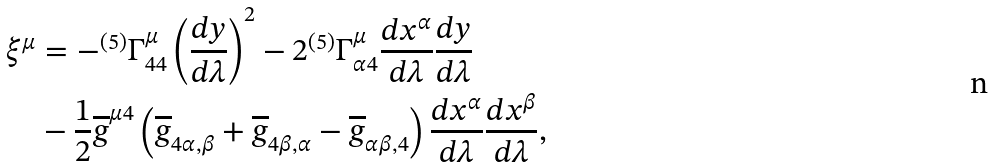Convert formula to latex. <formula><loc_0><loc_0><loc_500><loc_500>\xi ^ { \mu } & = - ^ { ( 5 ) } \Gamma _ { 4 4 } ^ { \mu } \left ( \frac { d y } { d \lambda } \right ) ^ { 2 } - 2 ^ { ( 5 ) } \Gamma _ { \alpha 4 } ^ { \mu } \frac { d x ^ { \alpha } } { d \lambda } \frac { d y } { d \lambda } \\ & - \frac { 1 } { 2 } \overline { g } ^ { \mu 4 } \left ( \overline { g } _ { 4 \alpha , \beta } + \overline { g } _ { 4 \beta , \alpha } - \overline { g } _ { \alpha \beta , 4 } \right ) \frac { d x ^ { \alpha } } { d \lambda } \frac { d x ^ { \beta } } { d \lambda } ,</formula> 